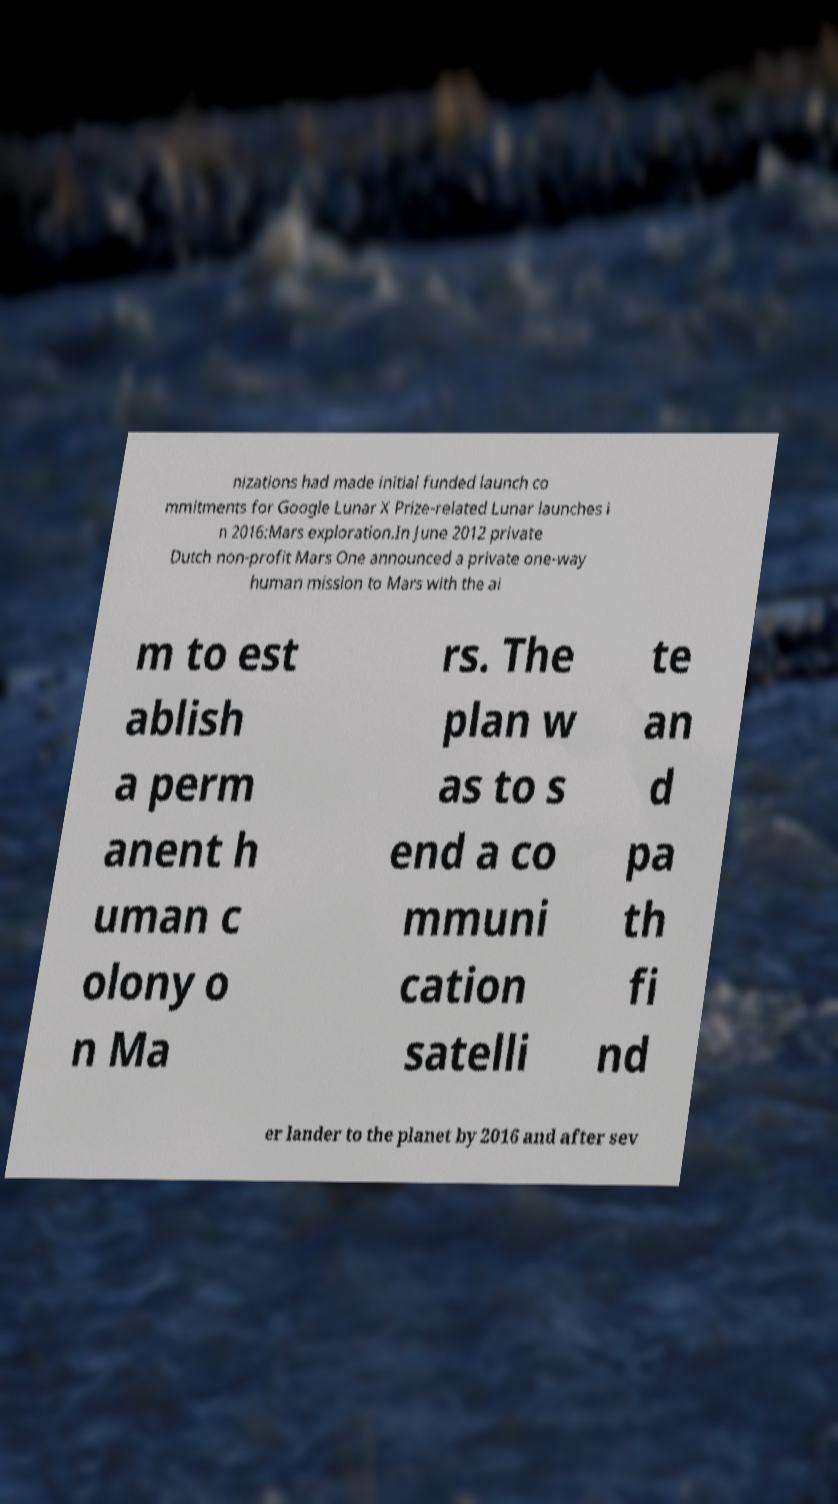Could you assist in decoding the text presented in this image and type it out clearly? nizations had made initial funded launch co mmitments for Google Lunar X Prize-related Lunar launches i n 2016:Mars exploration.In June 2012 private Dutch non-profit Mars One announced a private one-way human mission to Mars with the ai m to est ablish a perm anent h uman c olony o n Ma rs. The plan w as to s end a co mmuni cation satelli te an d pa th fi nd er lander to the planet by 2016 and after sev 